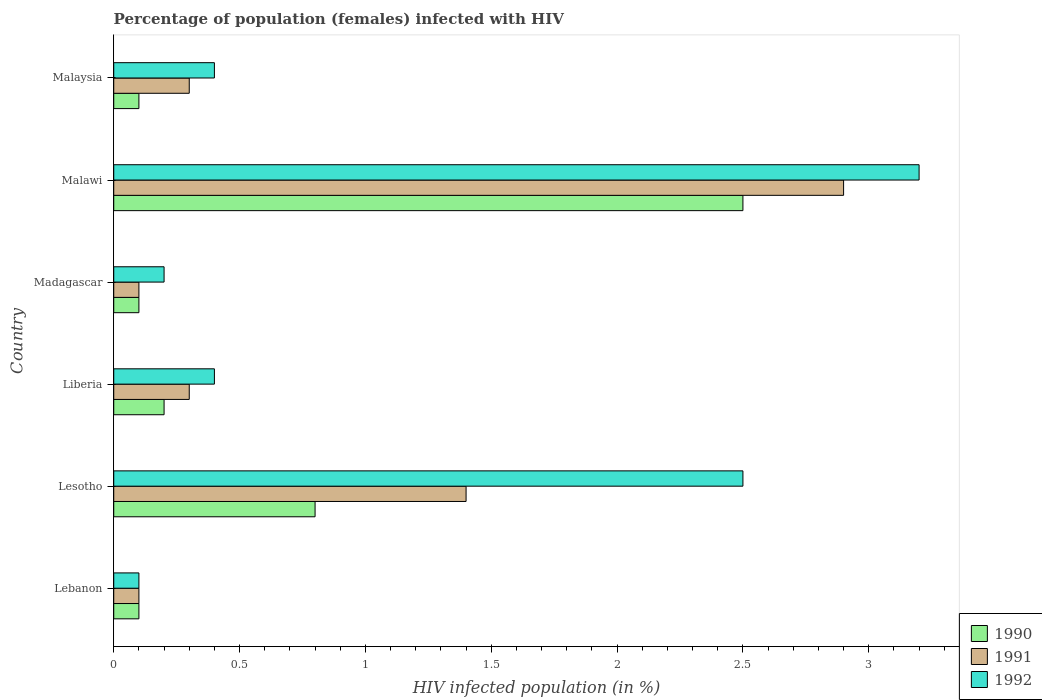How many different coloured bars are there?
Your answer should be compact. 3. How many groups of bars are there?
Make the answer very short. 6. Are the number of bars per tick equal to the number of legend labels?
Provide a succinct answer. Yes. How many bars are there on the 2nd tick from the top?
Offer a terse response. 3. What is the label of the 5th group of bars from the top?
Make the answer very short. Lesotho. What is the percentage of HIV infected female population in 1992 in Malawi?
Give a very brief answer. 3.2. Across all countries, what is the maximum percentage of HIV infected female population in 1992?
Give a very brief answer. 3.2. Across all countries, what is the minimum percentage of HIV infected female population in 1991?
Your answer should be very brief. 0.1. In which country was the percentage of HIV infected female population in 1992 maximum?
Your answer should be very brief. Malawi. In which country was the percentage of HIV infected female population in 1992 minimum?
Give a very brief answer. Lebanon. What is the total percentage of HIV infected female population in 1992 in the graph?
Provide a succinct answer. 6.8. What is the difference between the percentage of HIV infected female population in 1990 in Liberia and that in Malawi?
Provide a succinct answer. -2.3. What is the difference between the percentage of HIV infected female population in 1991 in Lebanon and the percentage of HIV infected female population in 1992 in Madagascar?
Offer a terse response. -0.1. What is the difference between the percentage of HIV infected female population in 1992 and percentage of HIV infected female population in 1991 in Malawi?
Give a very brief answer. 0.3. What is the ratio of the percentage of HIV infected female population in 1992 in Lebanon to that in Liberia?
Offer a terse response. 0.25. Is the percentage of HIV infected female population in 1992 in Malawi less than that in Malaysia?
Provide a succinct answer. No. What is the difference between the highest and the lowest percentage of HIV infected female population in 1990?
Provide a short and direct response. 2.4. In how many countries, is the percentage of HIV infected female population in 1992 greater than the average percentage of HIV infected female population in 1992 taken over all countries?
Keep it short and to the point. 2. Is the sum of the percentage of HIV infected female population in 1991 in Lebanon and Malawi greater than the maximum percentage of HIV infected female population in 1992 across all countries?
Make the answer very short. No. Is it the case that in every country, the sum of the percentage of HIV infected female population in 1991 and percentage of HIV infected female population in 1992 is greater than the percentage of HIV infected female population in 1990?
Offer a terse response. Yes. How many bars are there?
Make the answer very short. 18. How many countries are there in the graph?
Your answer should be very brief. 6. Are the values on the major ticks of X-axis written in scientific E-notation?
Provide a succinct answer. No. Does the graph contain any zero values?
Provide a succinct answer. No. Does the graph contain grids?
Your answer should be compact. No. Where does the legend appear in the graph?
Provide a succinct answer. Bottom right. How many legend labels are there?
Your answer should be very brief. 3. What is the title of the graph?
Make the answer very short. Percentage of population (females) infected with HIV. Does "2011" appear as one of the legend labels in the graph?
Provide a short and direct response. No. What is the label or title of the X-axis?
Provide a succinct answer. HIV infected population (in %). What is the HIV infected population (in %) of 1991 in Lebanon?
Provide a succinct answer. 0.1. What is the HIV infected population (in %) in 1991 in Lesotho?
Your answer should be very brief. 1.4. What is the HIV infected population (in %) of 1992 in Lesotho?
Provide a short and direct response. 2.5. What is the HIV infected population (in %) of 1990 in Liberia?
Provide a short and direct response. 0.2. What is the HIV infected population (in %) in 1990 in Madagascar?
Your response must be concise. 0.1. What is the HIV infected population (in %) in 1992 in Madagascar?
Provide a short and direct response. 0.2. What is the HIV infected population (in %) of 1992 in Malawi?
Offer a very short reply. 3.2. What is the HIV infected population (in %) of 1991 in Malaysia?
Ensure brevity in your answer.  0.3. What is the HIV infected population (in %) of 1992 in Malaysia?
Offer a very short reply. 0.4. Across all countries, what is the maximum HIV infected population (in %) in 1990?
Keep it short and to the point. 2.5. Across all countries, what is the maximum HIV infected population (in %) in 1991?
Your response must be concise. 2.9. Across all countries, what is the minimum HIV infected population (in %) in 1990?
Offer a very short reply. 0.1. Across all countries, what is the minimum HIV infected population (in %) of 1992?
Your answer should be very brief. 0.1. What is the total HIV infected population (in %) in 1991 in the graph?
Offer a very short reply. 5.1. What is the total HIV infected population (in %) of 1992 in the graph?
Keep it short and to the point. 6.8. What is the difference between the HIV infected population (in %) in 1991 in Lebanon and that in Lesotho?
Your answer should be compact. -1.3. What is the difference between the HIV infected population (in %) in 1990 in Lebanon and that in Liberia?
Give a very brief answer. -0.1. What is the difference between the HIV infected population (in %) in 1992 in Lebanon and that in Malawi?
Keep it short and to the point. -3.1. What is the difference between the HIV infected population (in %) in 1991 in Lebanon and that in Malaysia?
Ensure brevity in your answer.  -0.2. What is the difference between the HIV infected population (in %) of 1992 in Lebanon and that in Malaysia?
Your response must be concise. -0.3. What is the difference between the HIV infected population (in %) in 1991 in Lesotho and that in Liberia?
Offer a terse response. 1.1. What is the difference between the HIV infected population (in %) of 1992 in Lesotho and that in Liberia?
Your response must be concise. 2.1. What is the difference between the HIV infected population (in %) of 1990 in Lesotho and that in Malawi?
Give a very brief answer. -1.7. What is the difference between the HIV infected population (in %) in 1992 in Lesotho and that in Malawi?
Ensure brevity in your answer.  -0.7. What is the difference between the HIV infected population (in %) in 1991 in Lesotho and that in Malaysia?
Your answer should be very brief. 1.1. What is the difference between the HIV infected population (in %) of 1992 in Liberia and that in Madagascar?
Your answer should be compact. 0.2. What is the difference between the HIV infected population (in %) in 1990 in Liberia and that in Malawi?
Offer a terse response. -2.3. What is the difference between the HIV infected population (in %) in 1992 in Liberia and that in Malawi?
Your answer should be very brief. -2.8. What is the difference between the HIV infected population (in %) in 1991 in Liberia and that in Malaysia?
Ensure brevity in your answer.  0. What is the difference between the HIV infected population (in %) of 1992 in Liberia and that in Malaysia?
Offer a very short reply. 0. What is the difference between the HIV infected population (in %) in 1992 in Madagascar and that in Malawi?
Provide a succinct answer. -3. What is the difference between the HIV infected population (in %) in 1990 in Madagascar and that in Malaysia?
Give a very brief answer. 0. What is the difference between the HIV infected population (in %) of 1991 in Madagascar and that in Malaysia?
Offer a terse response. -0.2. What is the difference between the HIV infected population (in %) of 1992 in Madagascar and that in Malaysia?
Your answer should be compact. -0.2. What is the difference between the HIV infected population (in %) of 1991 in Malawi and that in Malaysia?
Your answer should be very brief. 2.6. What is the difference between the HIV infected population (in %) of 1992 in Malawi and that in Malaysia?
Provide a short and direct response. 2.8. What is the difference between the HIV infected population (in %) of 1990 in Lebanon and the HIV infected population (in %) of 1991 in Lesotho?
Offer a very short reply. -1.3. What is the difference between the HIV infected population (in %) in 1990 in Lebanon and the HIV infected population (in %) in 1992 in Liberia?
Give a very brief answer. -0.3. What is the difference between the HIV infected population (in %) in 1991 in Lebanon and the HIV infected population (in %) in 1992 in Liberia?
Keep it short and to the point. -0.3. What is the difference between the HIV infected population (in %) of 1990 in Lebanon and the HIV infected population (in %) of 1991 in Malawi?
Make the answer very short. -2.8. What is the difference between the HIV infected population (in %) in 1990 in Lebanon and the HIV infected population (in %) in 1992 in Malawi?
Ensure brevity in your answer.  -3.1. What is the difference between the HIV infected population (in %) of 1991 in Lebanon and the HIV infected population (in %) of 1992 in Malawi?
Offer a terse response. -3.1. What is the difference between the HIV infected population (in %) in 1990 in Lebanon and the HIV infected population (in %) in 1992 in Malaysia?
Your answer should be compact. -0.3. What is the difference between the HIV infected population (in %) in 1990 in Lesotho and the HIV infected population (in %) in 1991 in Madagascar?
Your answer should be compact. 0.7. What is the difference between the HIV infected population (in %) in 1990 in Lesotho and the HIV infected population (in %) in 1992 in Madagascar?
Your answer should be very brief. 0.6. What is the difference between the HIV infected population (in %) in 1991 in Lesotho and the HIV infected population (in %) in 1992 in Malawi?
Provide a short and direct response. -1.8. What is the difference between the HIV infected population (in %) in 1990 in Lesotho and the HIV infected population (in %) in 1991 in Malaysia?
Keep it short and to the point. 0.5. What is the difference between the HIV infected population (in %) of 1991 in Lesotho and the HIV infected population (in %) of 1992 in Malaysia?
Your answer should be compact. 1. What is the difference between the HIV infected population (in %) in 1991 in Liberia and the HIV infected population (in %) in 1992 in Madagascar?
Offer a terse response. 0.1. What is the difference between the HIV infected population (in %) in 1991 in Liberia and the HIV infected population (in %) in 1992 in Malawi?
Your response must be concise. -2.9. What is the difference between the HIV infected population (in %) of 1990 in Liberia and the HIV infected population (in %) of 1991 in Malaysia?
Your response must be concise. -0.1. What is the difference between the HIV infected population (in %) in 1990 in Liberia and the HIV infected population (in %) in 1992 in Malaysia?
Keep it short and to the point. -0.2. What is the difference between the HIV infected population (in %) in 1991 in Liberia and the HIV infected population (in %) in 1992 in Malaysia?
Offer a very short reply. -0.1. What is the difference between the HIV infected population (in %) of 1990 in Madagascar and the HIV infected population (in %) of 1991 in Malawi?
Keep it short and to the point. -2.8. What is the difference between the HIV infected population (in %) of 1990 in Madagascar and the HIV infected population (in %) of 1991 in Malaysia?
Give a very brief answer. -0.2. What is the difference between the HIV infected population (in %) of 1990 in Madagascar and the HIV infected population (in %) of 1992 in Malaysia?
Your response must be concise. -0.3. What is the difference between the HIV infected population (in %) of 1991 in Malawi and the HIV infected population (in %) of 1992 in Malaysia?
Provide a short and direct response. 2.5. What is the average HIV infected population (in %) of 1990 per country?
Your answer should be compact. 0.63. What is the average HIV infected population (in %) in 1992 per country?
Your answer should be very brief. 1.13. What is the difference between the HIV infected population (in %) in 1990 and HIV infected population (in %) in 1992 in Lebanon?
Provide a short and direct response. 0. What is the difference between the HIV infected population (in %) in 1991 and HIV infected population (in %) in 1992 in Lebanon?
Ensure brevity in your answer.  0. What is the difference between the HIV infected population (in %) of 1990 and HIV infected population (in %) of 1991 in Lesotho?
Offer a terse response. -0.6. What is the difference between the HIV infected population (in %) in 1990 and HIV infected population (in %) in 1992 in Lesotho?
Provide a succinct answer. -1.7. What is the difference between the HIV infected population (in %) in 1991 and HIV infected population (in %) in 1992 in Lesotho?
Ensure brevity in your answer.  -1.1. What is the difference between the HIV infected population (in %) of 1990 and HIV infected population (in %) of 1992 in Liberia?
Ensure brevity in your answer.  -0.2. What is the difference between the HIV infected population (in %) of 1991 and HIV infected population (in %) of 1992 in Madagascar?
Ensure brevity in your answer.  -0.1. What is the difference between the HIV infected population (in %) in 1990 and HIV infected population (in %) in 1992 in Malawi?
Your answer should be compact. -0.7. What is the difference between the HIV infected population (in %) of 1990 and HIV infected population (in %) of 1991 in Malaysia?
Make the answer very short. -0.2. What is the difference between the HIV infected population (in %) of 1991 and HIV infected population (in %) of 1992 in Malaysia?
Give a very brief answer. -0.1. What is the ratio of the HIV infected population (in %) in 1990 in Lebanon to that in Lesotho?
Make the answer very short. 0.12. What is the ratio of the HIV infected population (in %) in 1991 in Lebanon to that in Lesotho?
Provide a short and direct response. 0.07. What is the ratio of the HIV infected population (in %) in 1992 in Lebanon to that in Madagascar?
Give a very brief answer. 0.5. What is the ratio of the HIV infected population (in %) of 1990 in Lebanon to that in Malawi?
Ensure brevity in your answer.  0.04. What is the ratio of the HIV infected population (in %) in 1991 in Lebanon to that in Malawi?
Your response must be concise. 0.03. What is the ratio of the HIV infected population (in %) in 1992 in Lebanon to that in Malawi?
Your answer should be compact. 0.03. What is the ratio of the HIV infected population (in %) of 1992 in Lebanon to that in Malaysia?
Offer a terse response. 0.25. What is the ratio of the HIV infected population (in %) in 1991 in Lesotho to that in Liberia?
Provide a succinct answer. 4.67. What is the ratio of the HIV infected population (in %) in 1992 in Lesotho to that in Liberia?
Your answer should be compact. 6.25. What is the ratio of the HIV infected population (in %) in 1990 in Lesotho to that in Malawi?
Offer a very short reply. 0.32. What is the ratio of the HIV infected population (in %) of 1991 in Lesotho to that in Malawi?
Ensure brevity in your answer.  0.48. What is the ratio of the HIV infected population (in %) of 1992 in Lesotho to that in Malawi?
Offer a very short reply. 0.78. What is the ratio of the HIV infected population (in %) in 1991 in Lesotho to that in Malaysia?
Make the answer very short. 4.67. What is the ratio of the HIV infected population (in %) of 1992 in Lesotho to that in Malaysia?
Your answer should be very brief. 6.25. What is the ratio of the HIV infected population (in %) of 1990 in Liberia to that in Malawi?
Ensure brevity in your answer.  0.08. What is the ratio of the HIV infected population (in %) of 1991 in Liberia to that in Malawi?
Your answer should be very brief. 0.1. What is the ratio of the HIV infected population (in %) in 1992 in Liberia to that in Malawi?
Make the answer very short. 0.12. What is the ratio of the HIV infected population (in %) in 1991 in Liberia to that in Malaysia?
Offer a terse response. 1. What is the ratio of the HIV infected population (in %) of 1992 in Liberia to that in Malaysia?
Provide a short and direct response. 1. What is the ratio of the HIV infected population (in %) of 1990 in Madagascar to that in Malawi?
Your answer should be very brief. 0.04. What is the ratio of the HIV infected population (in %) in 1991 in Madagascar to that in Malawi?
Provide a short and direct response. 0.03. What is the ratio of the HIV infected population (in %) in 1992 in Madagascar to that in Malawi?
Your answer should be very brief. 0.06. What is the ratio of the HIV infected population (in %) in 1990 in Madagascar to that in Malaysia?
Your response must be concise. 1. What is the ratio of the HIV infected population (in %) of 1991 in Madagascar to that in Malaysia?
Make the answer very short. 0.33. What is the ratio of the HIV infected population (in %) of 1992 in Madagascar to that in Malaysia?
Ensure brevity in your answer.  0.5. What is the ratio of the HIV infected population (in %) of 1991 in Malawi to that in Malaysia?
Provide a short and direct response. 9.67. What is the difference between the highest and the second highest HIV infected population (in %) in 1990?
Offer a terse response. 1.7. What is the difference between the highest and the second highest HIV infected population (in %) in 1991?
Make the answer very short. 1.5. What is the difference between the highest and the second highest HIV infected population (in %) in 1992?
Your answer should be compact. 0.7. What is the difference between the highest and the lowest HIV infected population (in %) in 1990?
Provide a short and direct response. 2.4. 